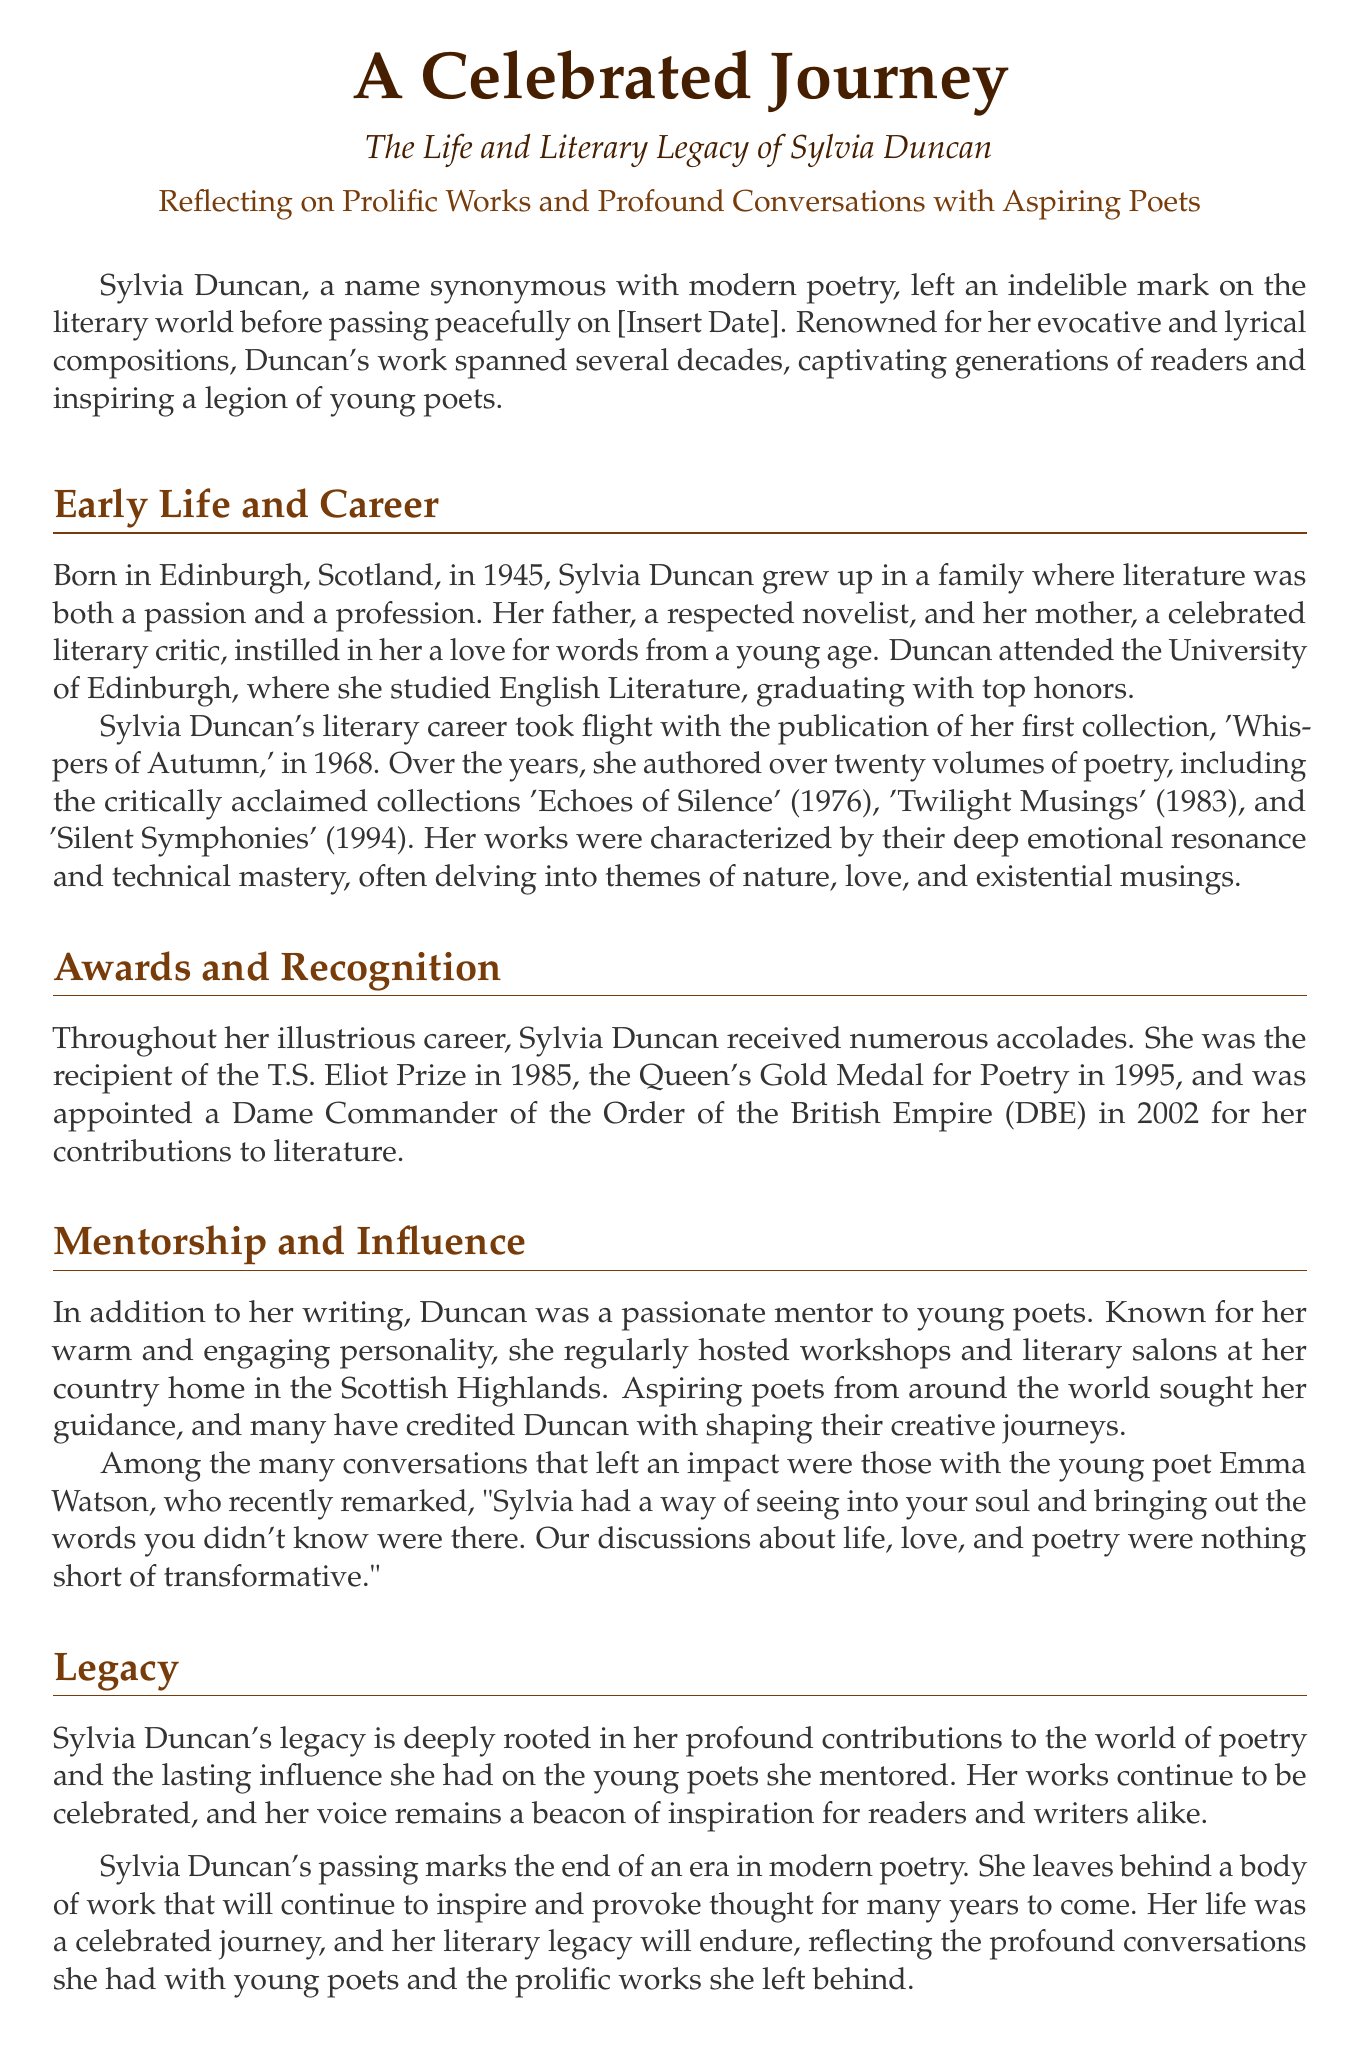What year was Sylvia Duncan born? The document states that Sylvia Duncan was born in 1945 in Edinburgh, Scotland.
Answer: 1945 How many volumes of poetry did Sylvia Duncan author? The document mentions that she authored over twenty volumes of poetry during her career.
Answer: over twenty Which collection earned Sylvia Duncan the T.S. Eliot Prize? According to the document, Sylvia Duncan received the T.S. Eliot Prize in 1985 for her poetry.
Answer: 1985 What themes did Duncan's works often explore? The document indicates that her works often delved into themes of nature, love, and existential musings.
Answer: nature, love, existential musings Who described Sylvia Duncan's influence as transformative? The document references a young poet, Emma Watson, who remarked about Duncan's transformative influence on their writing.
Answer: Emma Watson In what year did Sylvia Duncan receive the Queen's Gold Medal for Poetry? The document indicates that she received this award in 1995 for her contributions to literature.
Answer: 1995 What was the title of Sylvia Duncan's first poetry collection? The document mentions that her first collection was titled 'Whispers of Autumn,' published in 1968.
Answer: Whispers of Autumn What honor was Sylvia Duncan awarded in 2002? The document states that she was appointed a Dame Commander of the Order of the British Empire (DBE) in 2002.
Answer: DBE What was a significant aspect of Sylvia Duncan's career beyond writing? The document highlights that she was known for mentoring young poets and hosting workshops at her country home.
Answer: Mentorship 